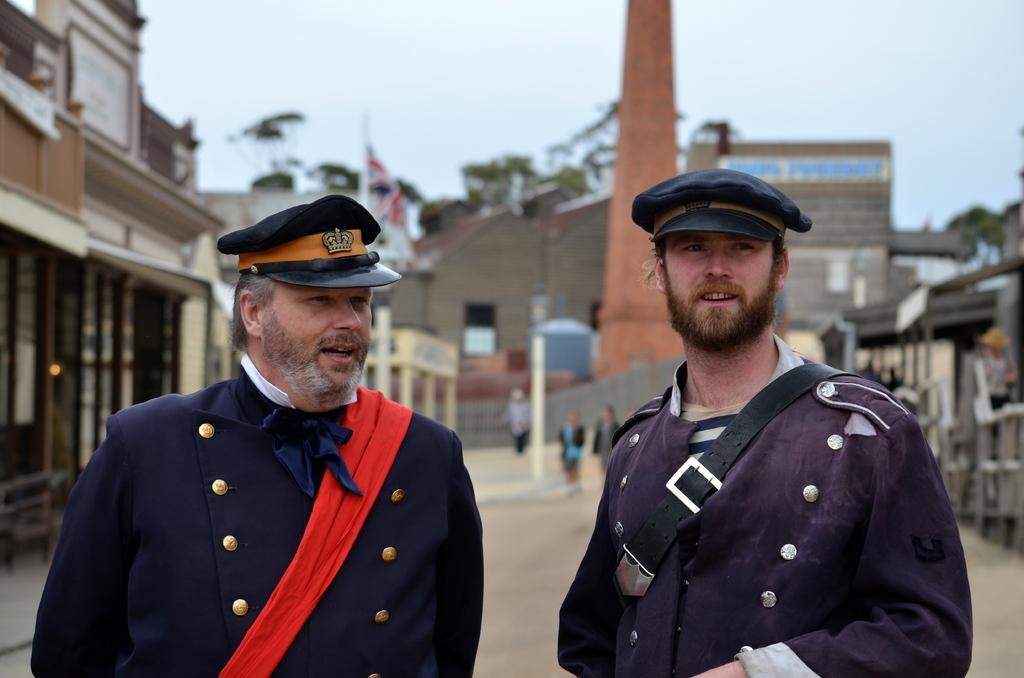Please provide a concise description of this image. In this image, there are a few people, buildings, poles. We can see the ground and some objects on the right. We can see a flag and the sky. 